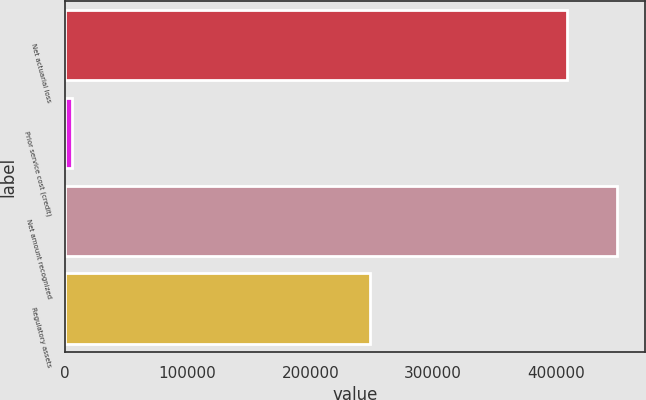Convert chart. <chart><loc_0><loc_0><loc_500><loc_500><bar_chart><fcel>Net actuarial loss<fcel>Prior service cost (credit)<fcel>Net amount recognized<fcel>Regulatory assets<nl><fcel>409129<fcel>5858<fcel>450042<fcel>248663<nl></chart> 